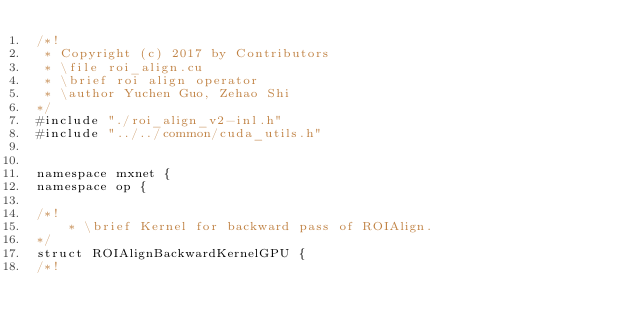<code> <loc_0><loc_0><loc_500><loc_500><_Cuda_>/*!
 * Copyright (c) 2017 by Contributors
 * \file roi_align.cu
 * \brief roi align operator
 * \author Yuchen Guo, Zehao Shi
*/
#include "./roi_align_v2-inl.h"
#include "../../common/cuda_utils.h"


namespace mxnet {
namespace op {

/*!
    * \brief Kernel for backward pass of ROIAlign.
*/
struct ROIAlignBackwardKernelGPU {
/*!</code> 